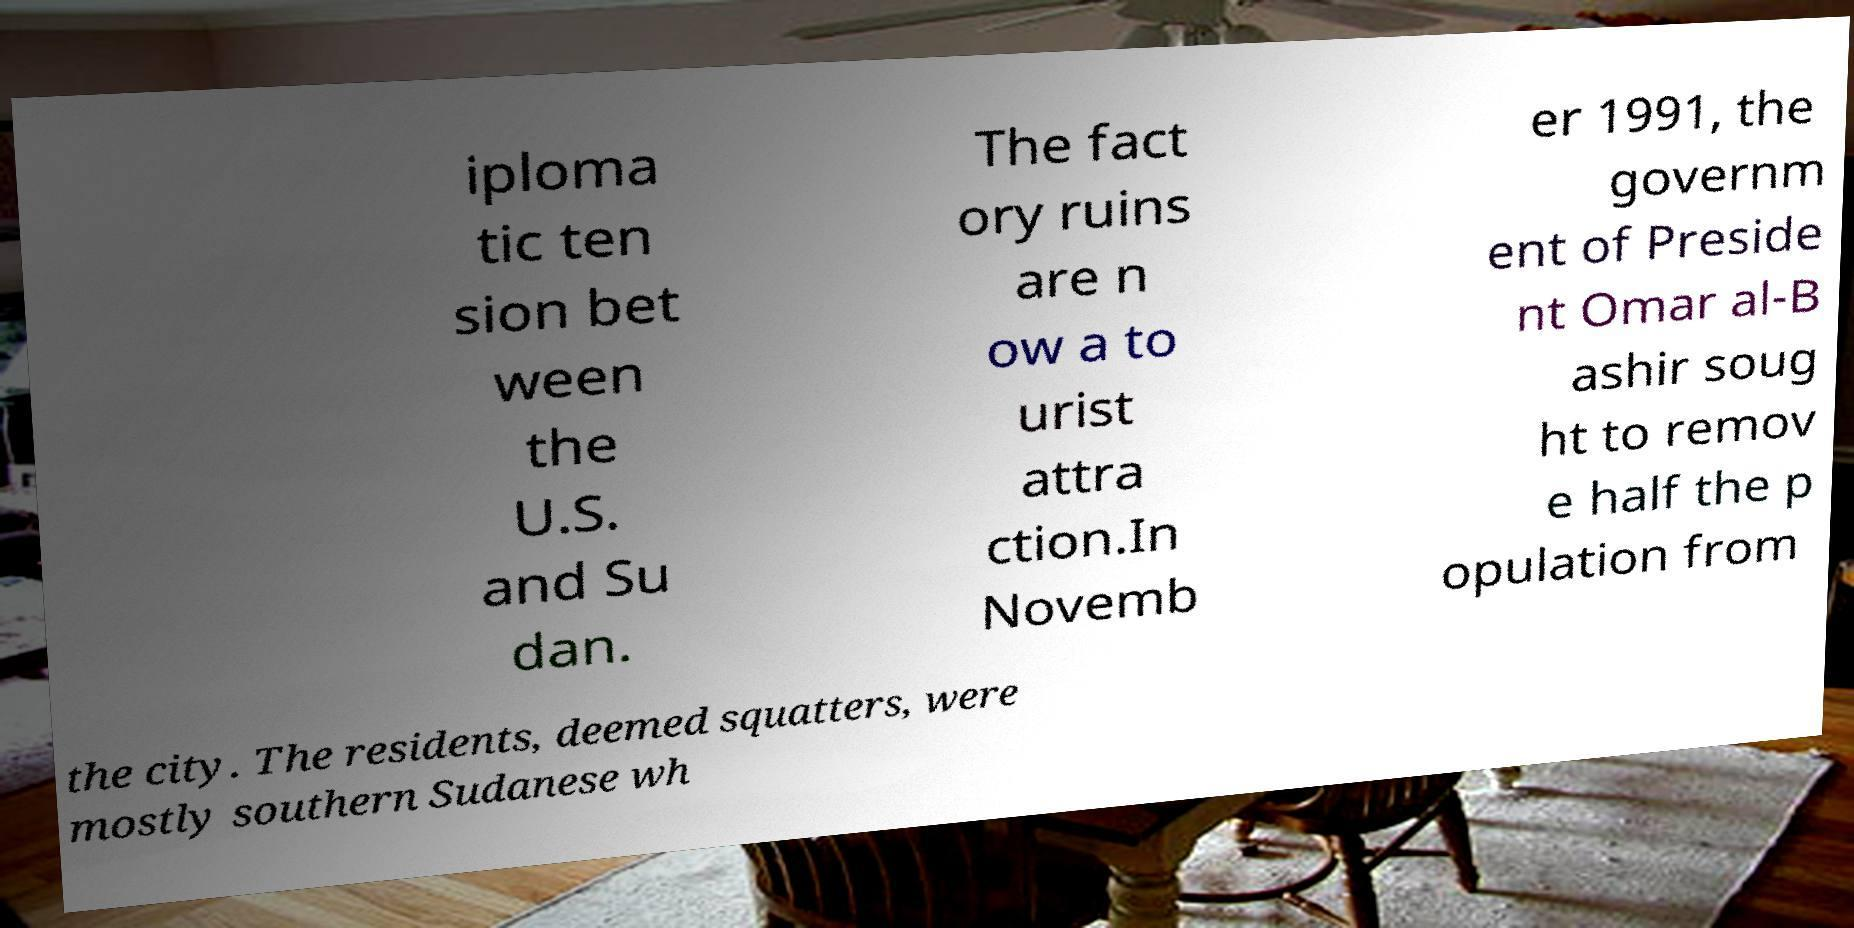What messages or text are displayed in this image? I need them in a readable, typed format. iploma tic ten sion bet ween the U.S. and Su dan. The fact ory ruins are n ow a to urist attra ction.In Novemb er 1991, the governm ent of Preside nt Omar al-B ashir soug ht to remov e half the p opulation from the city. The residents, deemed squatters, were mostly southern Sudanese wh 